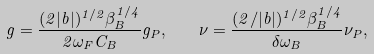<formula> <loc_0><loc_0><loc_500><loc_500>g = \frac { ( 2 | b | ) ^ { 1 / 2 } \beta _ { B } ^ { 1 / 4 } } { 2 \omega _ { F } C _ { B } } g _ { P } , \quad \nu = \frac { ( 2 / | b | ) ^ { 1 / 2 } \beta _ { B } ^ { 1 / 4 } } { \delta \omega _ { B } } \nu _ { P } ,</formula> 